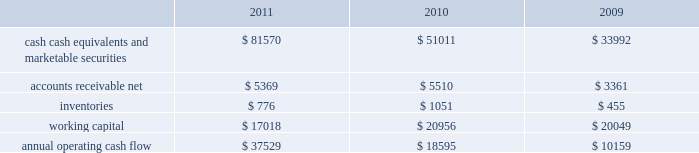35% ( 35 % ) due primarily to certain undistributed foreign earnings for which no u.s .
Taxes are provided because such earnings are intended to be indefinitely reinvested outside the u.s .
As of september 24 , 2011 , the company had deferred tax assets arising from deductible temporary differences , tax losses , and tax credits of $ 3.2 billion , and deferred tax liabilities of $ 9.2 billion .
Management believes it is more likely than not that forecasted income , including income that may be generated as a result of certain tax planning strategies , together with future reversals of existing taxable temporary differences , will be sufficient to fully recover the deferred tax assets .
The company will continue to evaluate the realizability of deferred tax assets quarterly by assessing the need for and amount of a valuation allowance .
The internal revenue service ( the 201cirs 201d ) has completed its field audit of the company 2019s federal income tax returns for the years 2004 through 2006 and proposed certain adjustments .
The company has contested certain of these adjustments through the irs appeals office .
The irs is currently examining the years 2007 through 2009 .
All irs audit issues for years prior to 2004 have been resolved .
In addition , the company is subject to audits by state , local , and foreign tax authorities .
Management believes that adequate provisions have been made for any adjustments that may result from tax examinations .
However , the outcome of tax audits cannot be predicted with certainty .
If any issues addressed in the company 2019s tax audits are resolved in a manner not consistent with management 2019s expectations , the company could be required to adjust its provision for income taxes in the period such resolution occurs .
Liquidity and capital resources the table presents selected financial information and statistics as of and for the three years ended september 24 , 2011 ( in millions ) : .
Cash , cash equivalents and marketable securities increased $ 30.6 billion or 60% ( 60 % ) during 2011 .
The principal components of this net increase was the cash generated by operating activities of $ 37.5 billion , which was partially offset by payments for acquisition of property , plant and equipment of $ 4.3 billion , payments for acquisition of intangible assets of $ 3.2 billion and payments made in connection with business acquisitions , net of cash acquired , of $ 244 million .
The company believes its existing balances of cash , cash equivalents and marketable securities will be sufficient to satisfy its working capital needs , capital asset purchases , outstanding commitments and other liquidity requirements associated with its existing operations over the next 12 months .
The company 2019s marketable securities investment portfolio is invested primarily in highly rated securities and its policy generally limits the amount of credit exposure to any one issuer .
The company 2019s investment policy requires investments to generally be investment grade with the objective of minimizing the potential risk of principal loss .
As of september 24 , 2011 and september 25 , 2010 , $ 54.3 billion and $ 30.8 billion , respectively , of the company 2019s cash , cash equivalents and marketable securities were held by foreign subsidiaries and are generally based in u.s .
Dollar-denominated holdings .
Amounts held by foreign subsidiaries are generally subject to u.s .
Income taxation on repatriation to the u.s .
Capital assets the company 2019s capital expenditures were $ 4.6 billion during 2011 , consisting of approximately $ 614 million for retail store facilities and $ 4.0 billion for other capital expenditures , including product tooling and manufacturing .
Inventories were what percent of working capital for 2009? 
Computations: (455 / 20049)
Answer: 0.02269. 35% ( 35 % ) due primarily to certain undistributed foreign earnings for which no u.s .
Taxes are provided because such earnings are intended to be indefinitely reinvested outside the u.s .
As of september 24 , 2011 , the company had deferred tax assets arising from deductible temporary differences , tax losses , and tax credits of $ 3.2 billion , and deferred tax liabilities of $ 9.2 billion .
Management believes it is more likely than not that forecasted income , including income that may be generated as a result of certain tax planning strategies , together with future reversals of existing taxable temporary differences , will be sufficient to fully recover the deferred tax assets .
The company will continue to evaluate the realizability of deferred tax assets quarterly by assessing the need for and amount of a valuation allowance .
The internal revenue service ( the 201cirs 201d ) has completed its field audit of the company 2019s federal income tax returns for the years 2004 through 2006 and proposed certain adjustments .
The company has contested certain of these adjustments through the irs appeals office .
The irs is currently examining the years 2007 through 2009 .
All irs audit issues for years prior to 2004 have been resolved .
In addition , the company is subject to audits by state , local , and foreign tax authorities .
Management believes that adequate provisions have been made for any adjustments that may result from tax examinations .
However , the outcome of tax audits cannot be predicted with certainty .
If any issues addressed in the company 2019s tax audits are resolved in a manner not consistent with management 2019s expectations , the company could be required to adjust its provision for income taxes in the period such resolution occurs .
Liquidity and capital resources the table presents selected financial information and statistics as of and for the three years ended september 24 , 2011 ( in millions ) : .
Cash , cash equivalents and marketable securities increased $ 30.6 billion or 60% ( 60 % ) during 2011 .
The principal components of this net increase was the cash generated by operating activities of $ 37.5 billion , which was partially offset by payments for acquisition of property , plant and equipment of $ 4.3 billion , payments for acquisition of intangible assets of $ 3.2 billion and payments made in connection with business acquisitions , net of cash acquired , of $ 244 million .
The company believes its existing balances of cash , cash equivalents and marketable securities will be sufficient to satisfy its working capital needs , capital asset purchases , outstanding commitments and other liquidity requirements associated with its existing operations over the next 12 months .
The company 2019s marketable securities investment portfolio is invested primarily in highly rated securities and its policy generally limits the amount of credit exposure to any one issuer .
The company 2019s investment policy requires investments to generally be investment grade with the objective of minimizing the potential risk of principal loss .
As of september 24 , 2011 and september 25 , 2010 , $ 54.3 billion and $ 30.8 billion , respectively , of the company 2019s cash , cash equivalents and marketable securities were held by foreign subsidiaries and are generally based in u.s .
Dollar-denominated holdings .
Amounts held by foreign subsidiaries are generally subject to u.s .
Income taxation on repatriation to the u.s .
Capital assets the company 2019s capital expenditures were $ 4.6 billion during 2011 , consisting of approximately $ 614 million for retail store facilities and $ 4.0 billion for other capital expenditures , including product tooling and manufacturing .
What year had the greatest amount of accounts receivable net? 
Computations: table_max(accounts receivable net, none)
Answer: 5510.0. 